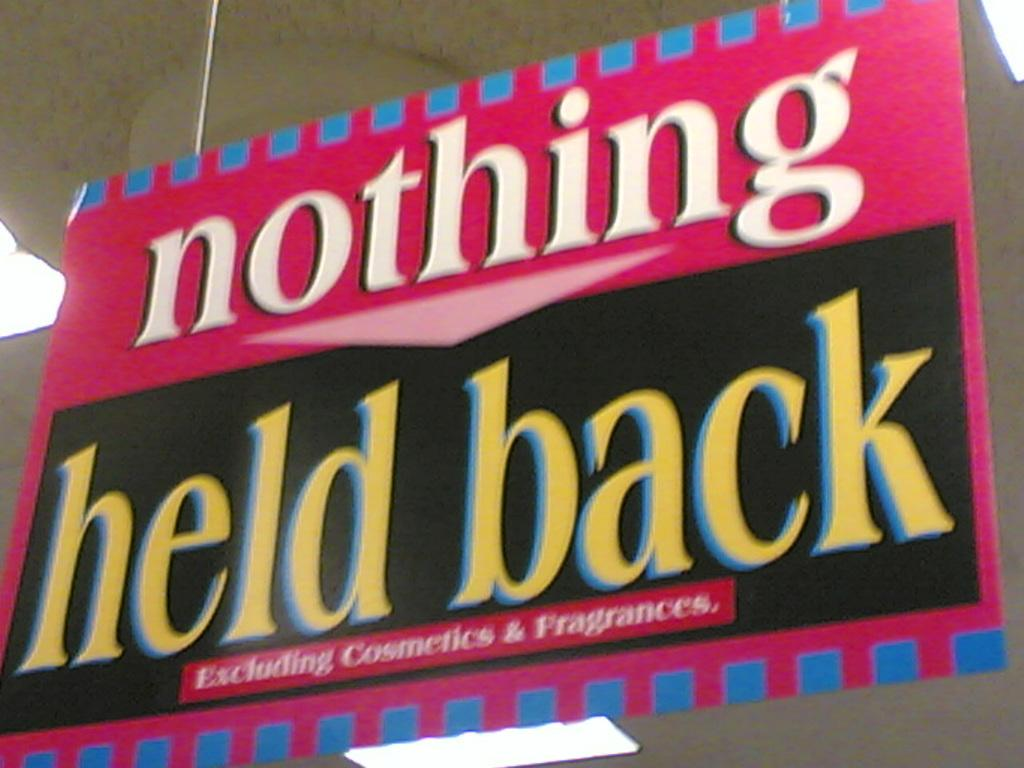Provide a one-sentence caption for the provided image. Nothing held back excluding cosmetics and fragrances pink banner. 